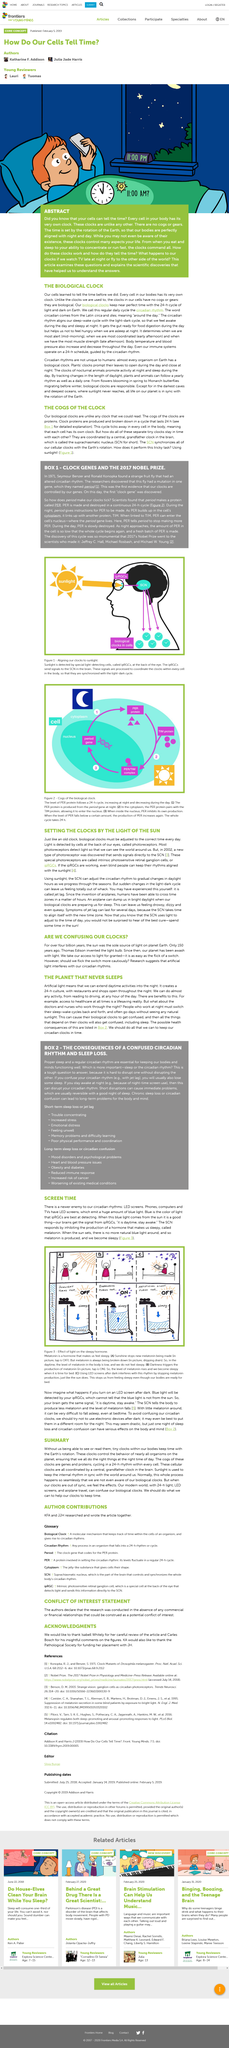Draw attention to some important aspects in this diagram. In the image, two objects can be seen that turn off the tap, which are sunlight and artificial light. All life on our planet is in sync with the rotation of the Earth. The best cure for jet lag is spending time in the sun. LED screens emit a blue color of light. The term "period" refers to a gene or protein. Specifically, it is a gene. 